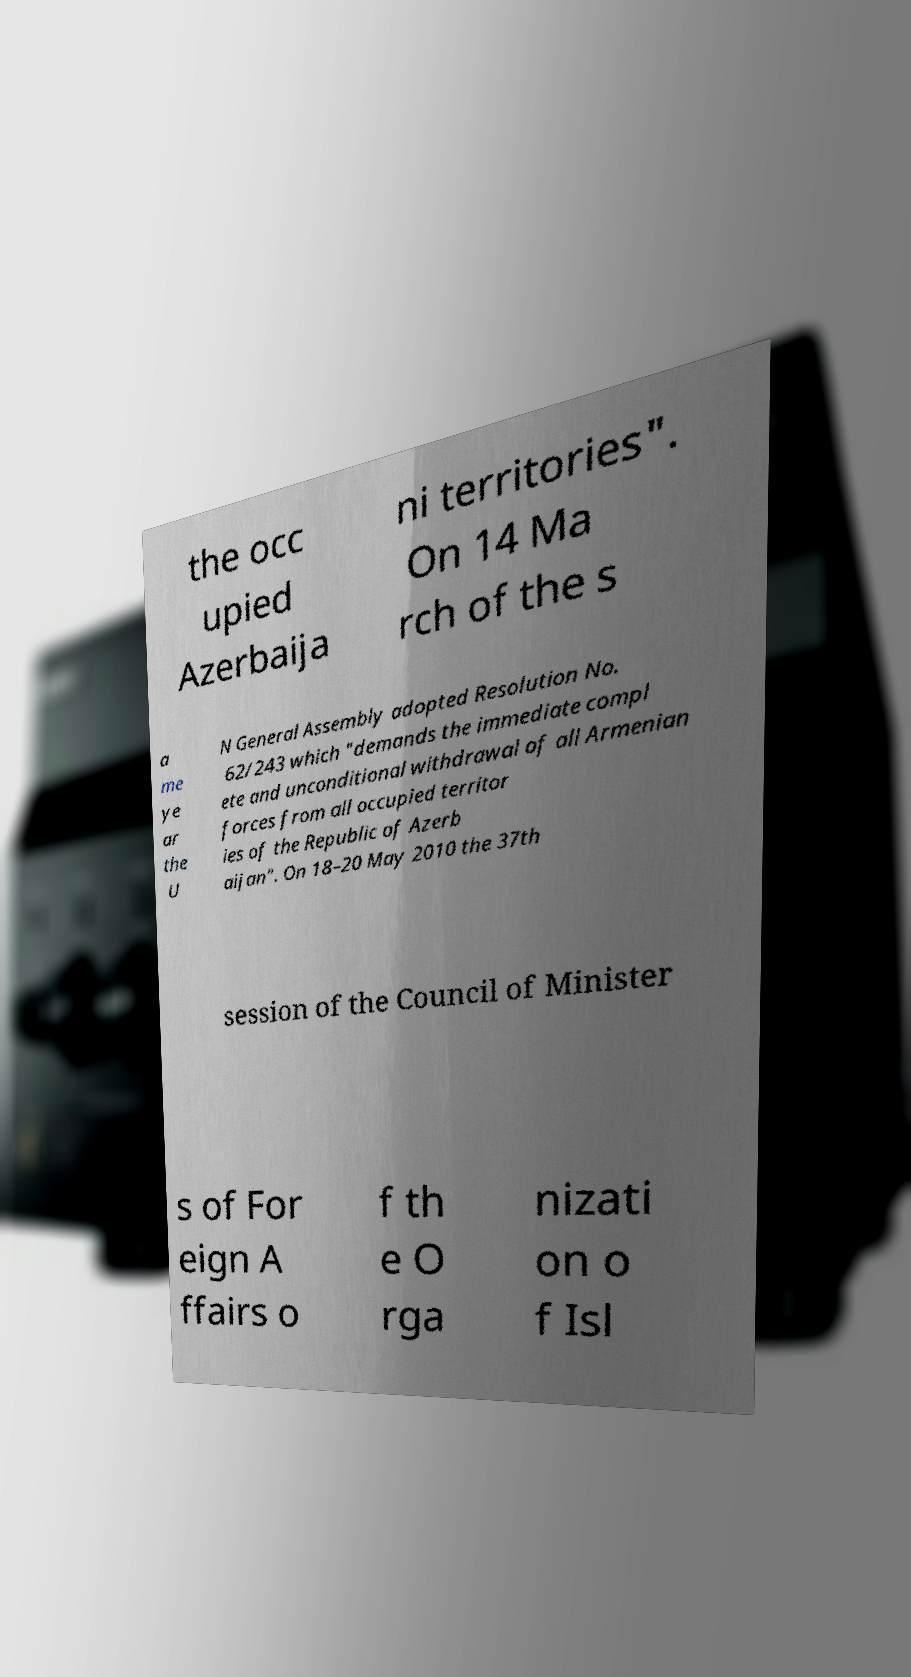For documentation purposes, I need the text within this image transcribed. Could you provide that? the occ upied Azerbaija ni territories". On 14 Ma rch of the s a me ye ar the U N General Assembly adopted Resolution No. 62/243 which "demands the immediate compl ete and unconditional withdrawal of all Armenian forces from all occupied territor ies of the Republic of Azerb aijan". On 18–20 May 2010 the 37th session of the Council of Minister s of For eign A ffairs o f th e O rga nizati on o f Isl 